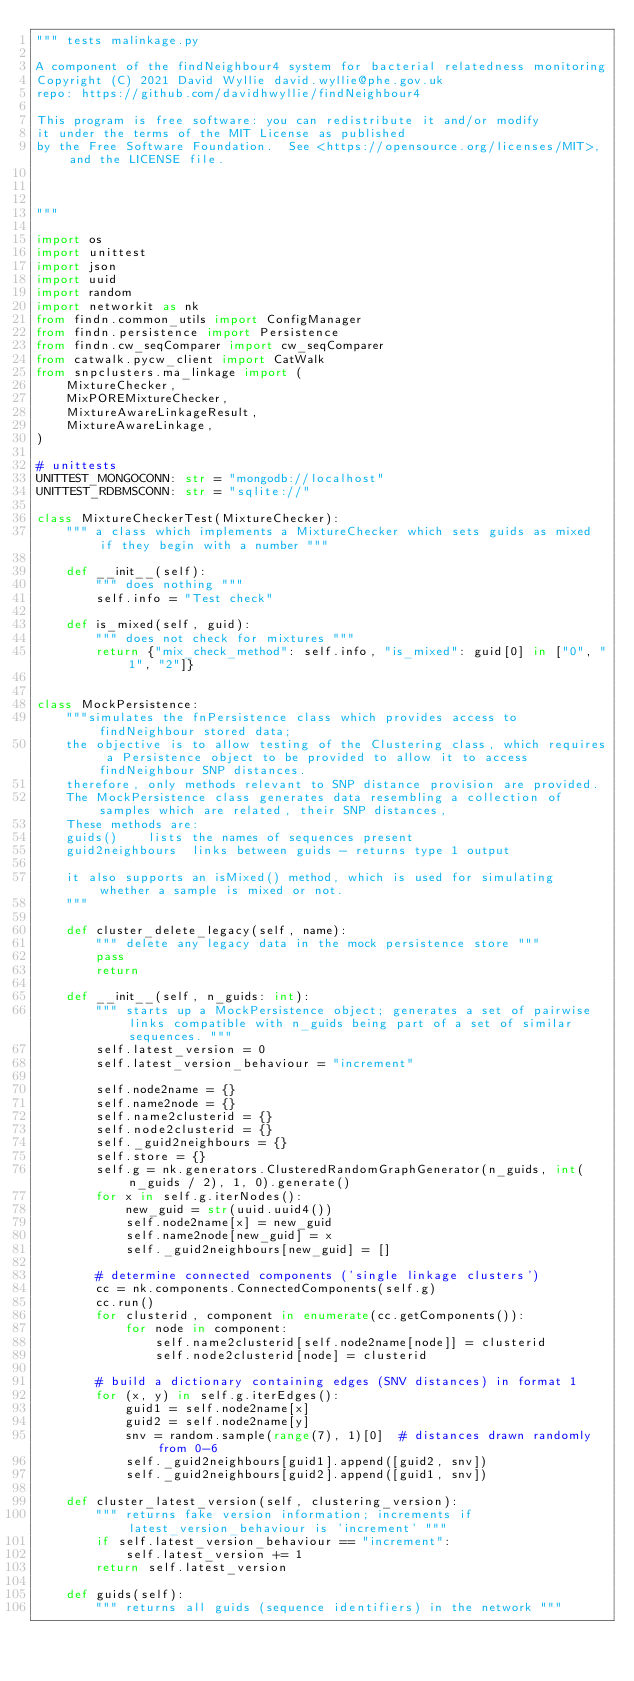<code> <loc_0><loc_0><loc_500><loc_500><_Python_>""" tests malinkage.py

A component of the findNeighbour4 system for bacterial relatedness monitoring
Copyright (C) 2021 David Wyllie david.wyllie@phe.gov.uk
repo: https://github.com/davidhwyllie/findNeighbour4

This program is free software: you can redistribute it and/or modify
it under the terms of the MIT License as published
by the Free Software Foundation.  See <https://opensource.org/licenses/MIT>, and the LICENSE file.

 

"""

import os
import unittest
import json
import uuid
import random
import networkit as nk
from findn.common_utils import ConfigManager
from findn.persistence import Persistence
from findn.cw_seqComparer import cw_seqComparer
from catwalk.pycw_client import CatWalk
from snpclusters.ma_linkage import (
    MixtureChecker,
    MixPOREMixtureChecker,
    MixtureAwareLinkageResult,
    MixtureAwareLinkage,
)

# unittests
UNITTEST_MONGOCONN: str = "mongodb://localhost"
UNITTEST_RDBMSCONN: str = "sqlite://"

class MixtureCheckerTest(MixtureChecker):
    """ a class which implements a MixtureChecker which sets guids as mixed if they begin with a number """

    def __init__(self):
        """ does nothing """
        self.info = "Test check"

    def is_mixed(self, guid):
        """ does not check for mixtures """
        return {"mix_check_method": self.info, "is_mixed": guid[0] in ["0", "1", "2"]}


class MockPersistence:
    """simulates the fnPersistence class which provides access to findNeighbour stored data;
    the objective is to allow testing of the Clustering class, which requires a Persistence object to be provided to allow it to access findNeighbour SNP distances.
    therefore, only methods relevant to SNP distance provision are provided.
    The MockPersistence class generates data resembling a collection of samples which are related, their SNP distances,
    These methods are:
    guids()    lists the names of sequences present
    guid2neighbours  links between guids - returns type 1 output

    it also supports an isMixed() method, which is used for simulating whether a sample is mixed or not.
    """

    def cluster_delete_legacy(self, name):
        """ delete any legacy data in the mock persistence store """
        pass
        return

    def __init__(self, n_guids: int):
        """ starts up a MockPersistence object; generates a set of pairwise links compatible with n_guids being part of a set of similar sequences. """
        self.latest_version = 0
        self.latest_version_behaviour = "increment"

        self.node2name = {}
        self.name2node = {}
        self.name2clusterid = {}
        self.node2clusterid = {}
        self._guid2neighbours = {}
        self.store = {}
        self.g = nk.generators.ClusteredRandomGraphGenerator(n_guids, int(n_guids / 2), 1, 0).generate()
        for x in self.g.iterNodes():
            new_guid = str(uuid.uuid4())
            self.node2name[x] = new_guid
            self.name2node[new_guid] = x
            self._guid2neighbours[new_guid] = []

        # determine connected components ('single linkage clusters')
        cc = nk.components.ConnectedComponents(self.g)
        cc.run()
        for clusterid, component in enumerate(cc.getComponents()):
            for node in component:
                self.name2clusterid[self.node2name[node]] = clusterid
                self.node2clusterid[node] = clusterid

        # build a dictionary containing edges (SNV distances) in format 1
        for (x, y) in self.g.iterEdges():
            guid1 = self.node2name[x]
            guid2 = self.node2name[y]
            snv = random.sample(range(7), 1)[0]  # distances drawn randomly from 0-6
            self._guid2neighbours[guid1].append([guid2, snv])
            self._guid2neighbours[guid2].append([guid1, snv])

    def cluster_latest_version(self, clustering_version):
        """ returns fake version information; increments if latest_version_behaviour is 'increment' """
        if self.latest_version_behaviour == "increment":
            self.latest_version += 1
        return self.latest_version

    def guids(self):
        """ returns all guids (sequence identifiers) in the network """</code> 